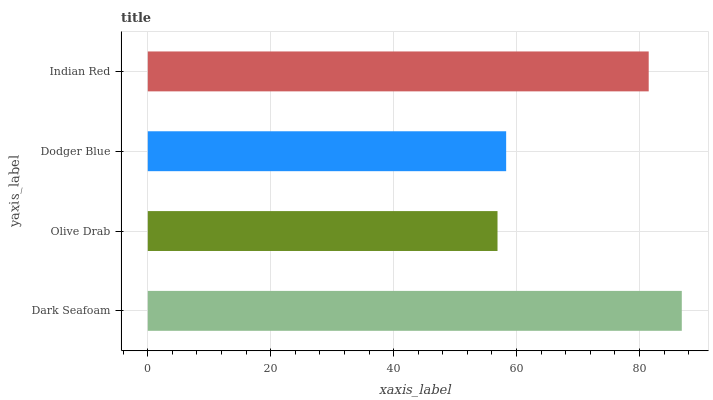Is Olive Drab the minimum?
Answer yes or no. Yes. Is Dark Seafoam the maximum?
Answer yes or no. Yes. Is Dodger Blue the minimum?
Answer yes or no. No. Is Dodger Blue the maximum?
Answer yes or no. No. Is Dodger Blue greater than Olive Drab?
Answer yes or no. Yes. Is Olive Drab less than Dodger Blue?
Answer yes or no. Yes. Is Olive Drab greater than Dodger Blue?
Answer yes or no. No. Is Dodger Blue less than Olive Drab?
Answer yes or no. No. Is Indian Red the high median?
Answer yes or no. Yes. Is Dodger Blue the low median?
Answer yes or no. Yes. Is Dark Seafoam the high median?
Answer yes or no. No. Is Indian Red the low median?
Answer yes or no. No. 